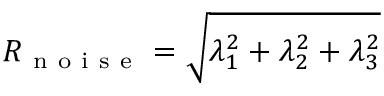<formula> <loc_0><loc_0><loc_500><loc_500>R _ { n o i s e } = \sqrt { \lambda _ { 1 } ^ { 2 } + \lambda _ { 2 } ^ { 2 } + \lambda _ { 3 } ^ { 2 } }</formula> 